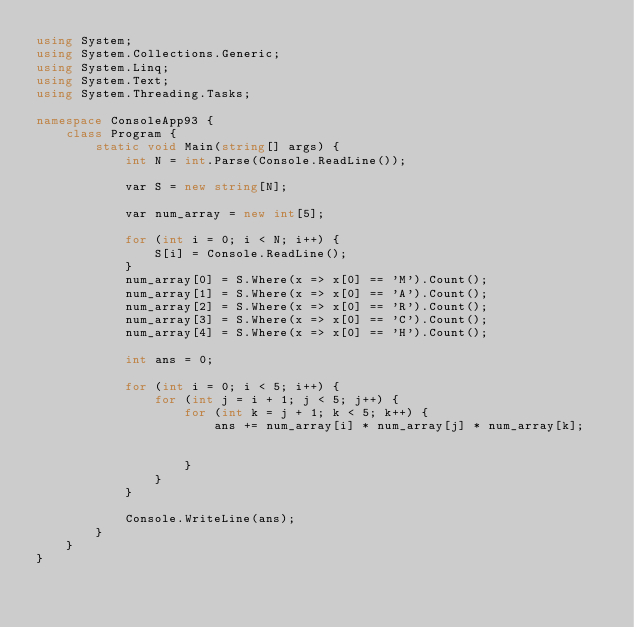Convert code to text. <code><loc_0><loc_0><loc_500><loc_500><_C#_>using System;
using System.Collections.Generic;
using System.Linq;
using System.Text;
using System.Threading.Tasks;

namespace ConsoleApp93 {
    class Program {
        static void Main(string[] args) {
            int N = int.Parse(Console.ReadLine());

            var S = new string[N];

            var num_array = new int[5];

            for (int i = 0; i < N; i++) {
                S[i] = Console.ReadLine();
            }
            num_array[0] = S.Where(x => x[0] == 'M').Count();
            num_array[1] = S.Where(x => x[0] == 'A').Count();
            num_array[2] = S.Where(x => x[0] == 'R').Count();
            num_array[3] = S.Where(x => x[0] == 'C').Count();
            num_array[4] = S.Where(x => x[0] == 'H').Count();

            int ans = 0;

            for (int i = 0; i < 5; i++) {
                for (int j = i + 1; j < 5; j++) {
                    for (int k = j + 1; k < 5; k++) {
                        ans += num_array[i] * num_array[j] * num_array[k];


                    }
                }
            }

            Console.WriteLine(ans);
        }
    }
}
</code> 